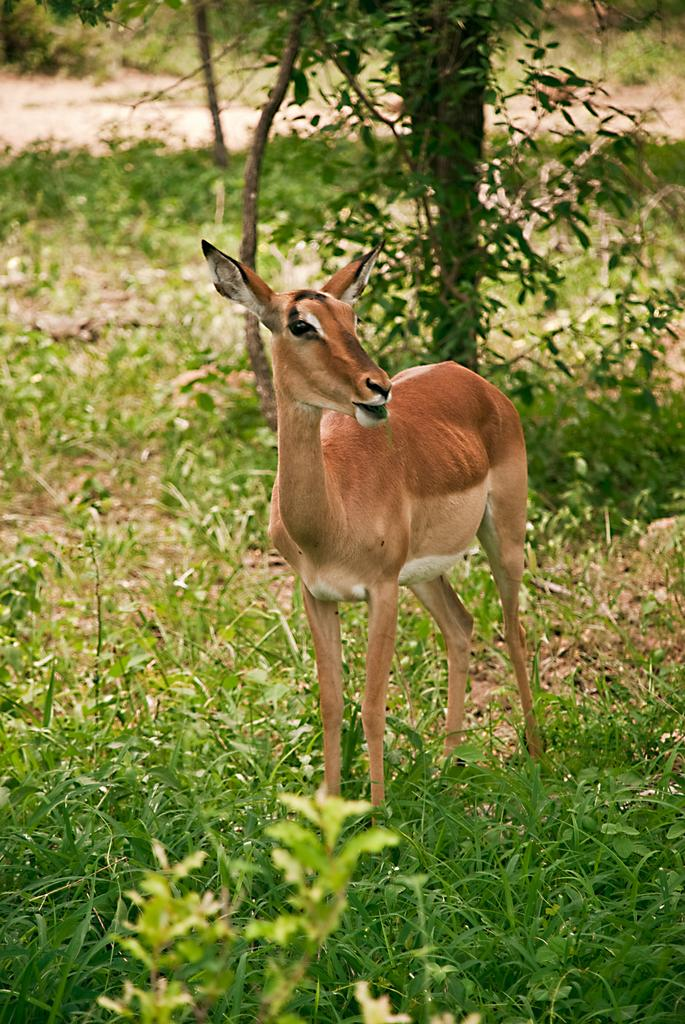What type of creature is in the image? There is an animal in the image. What is the animal standing on? The animal is standing on green grass. How many eyes can be seen on the note in the image? There is no note present in the image, and therefore no eyes can be seen on it. 